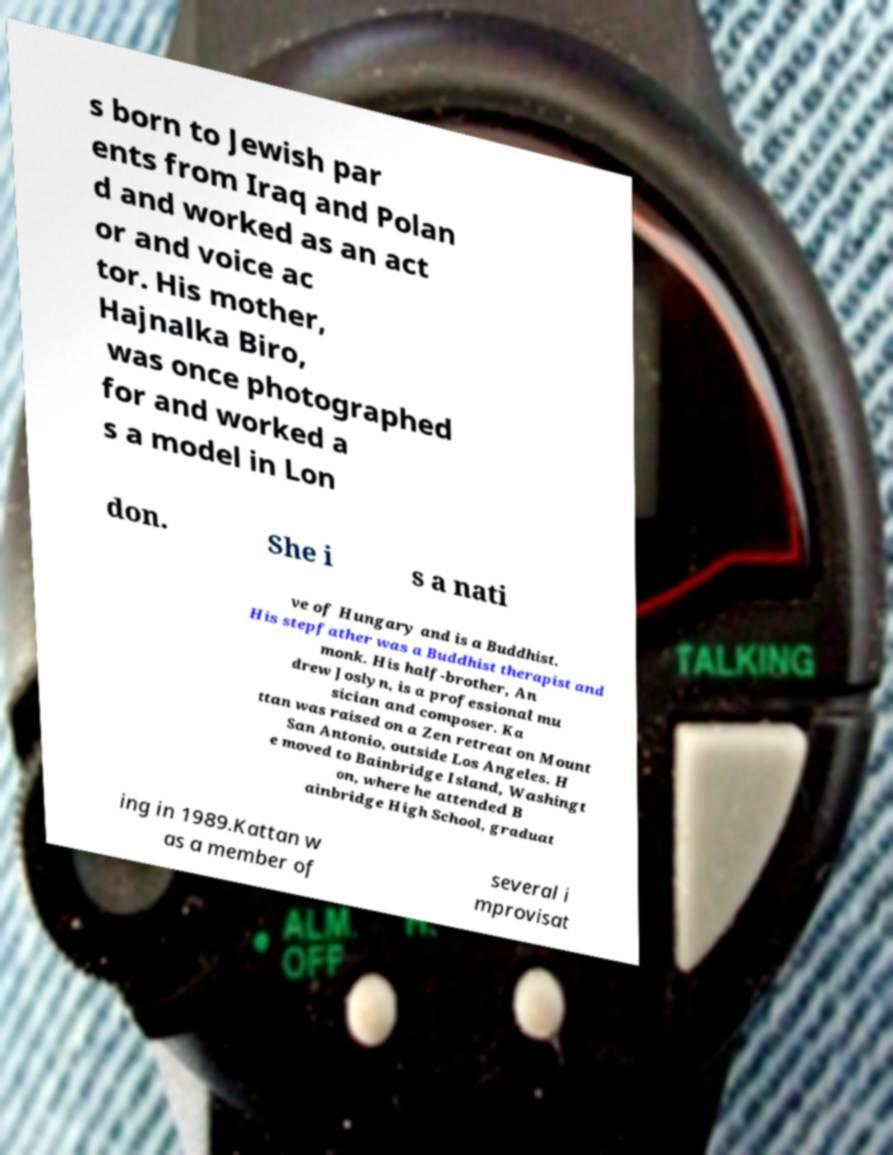There's text embedded in this image that I need extracted. Can you transcribe it verbatim? s born to Jewish par ents from Iraq and Polan d and worked as an act or and voice ac tor. His mother, Hajnalka Biro, was once photographed for and worked a s a model in Lon don. She i s a nati ve of Hungary and is a Buddhist. His stepfather was a Buddhist therapist and monk. His half-brother, An drew Joslyn, is a professional mu sician and composer. Ka ttan was raised on a Zen retreat on Mount San Antonio, outside Los Angeles. H e moved to Bainbridge Island, Washingt on, where he attended B ainbridge High School, graduat ing in 1989.Kattan w as a member of several i mprovisat 